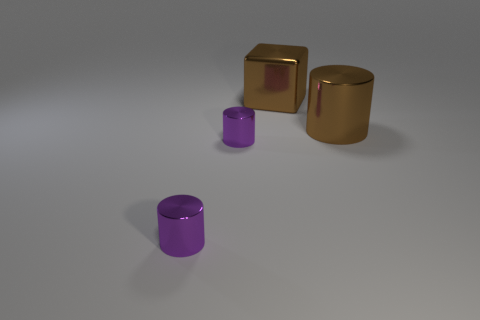Subtract all gray cylinders. Subtract all blue cubes. How many cylinders are left? 3 Add 4 metal things. How many objects exist? 8 Subtract all cylinders. How many objects are left? 1 Subtract all big green metal balls. Subtract all brown metal blocks. How many objects are left? 3 Add 3 small purple objects. How many small purple objects are left? 5 Add 3 big green metal balls. How many big green metal balls exist? 3 Subtract 0 yellow cubes. How many objects are left? 4 